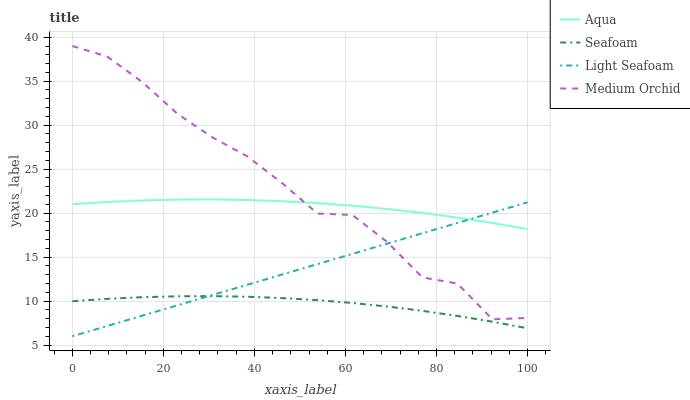Does Seafoam have the minimum area under the curve?
Answer yes or no. Yes. Does Medium Orchid have the maximum area under the curve?
Answer yes or no. Yes. Does Light Seafoam have the minimum area under the curve?
Answer yes or no. No. Does Light Seafoam have the maximum area under the curve?
Answer yes or no. No. Is Light Seafoam the smoothest?
Answer yes or no. Yes. Is Medium Orchid the roughest?
Answer yes or no. Yes. Is Aqua the smoothest?
Answer yes or no. No. Is Aqua the roughest?
Answer yes or no. No. Does Light Seafoam have the lowest value?
Answer yes or no. Yes. Does Aqua have the lowest value?
Answer yes or no. No. Does Medium Orchid have the highest value?
Answer yes or no. Yes. Does Light Seafoam have the highest value?
Answer yes or no. No. Is Seafoam less than Aqua?
Answer yes or no. Yes. Is Aqua greater than Seafoam?
Answer yes or no. Yes. Does Aqua intersect Light Seafoam?
Answer yes or no. Yes. Is Aqua less than Light Seafoam?
Answer yes or no. No. Is Aqua greater than Light Seafoam?
Answer yes or no. No. Does Seafoam intersect Aqua?
Answer yes or no. No. 